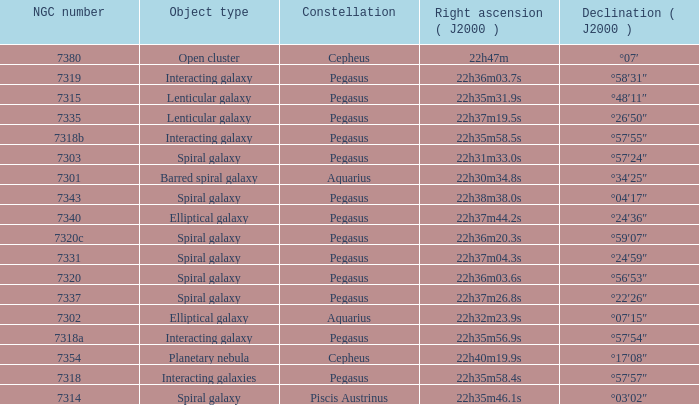What is the right ascension of Pegasus with a 7343 NGC? 22h38m38.0s. 